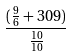<formula> <loc_0><loc_0><loc_500><loc_500>\frac { ( \frac { 9 } { 6 } + 3 0 9 ) } { \frac { 1 0 } { 1 0 } }</formula> 